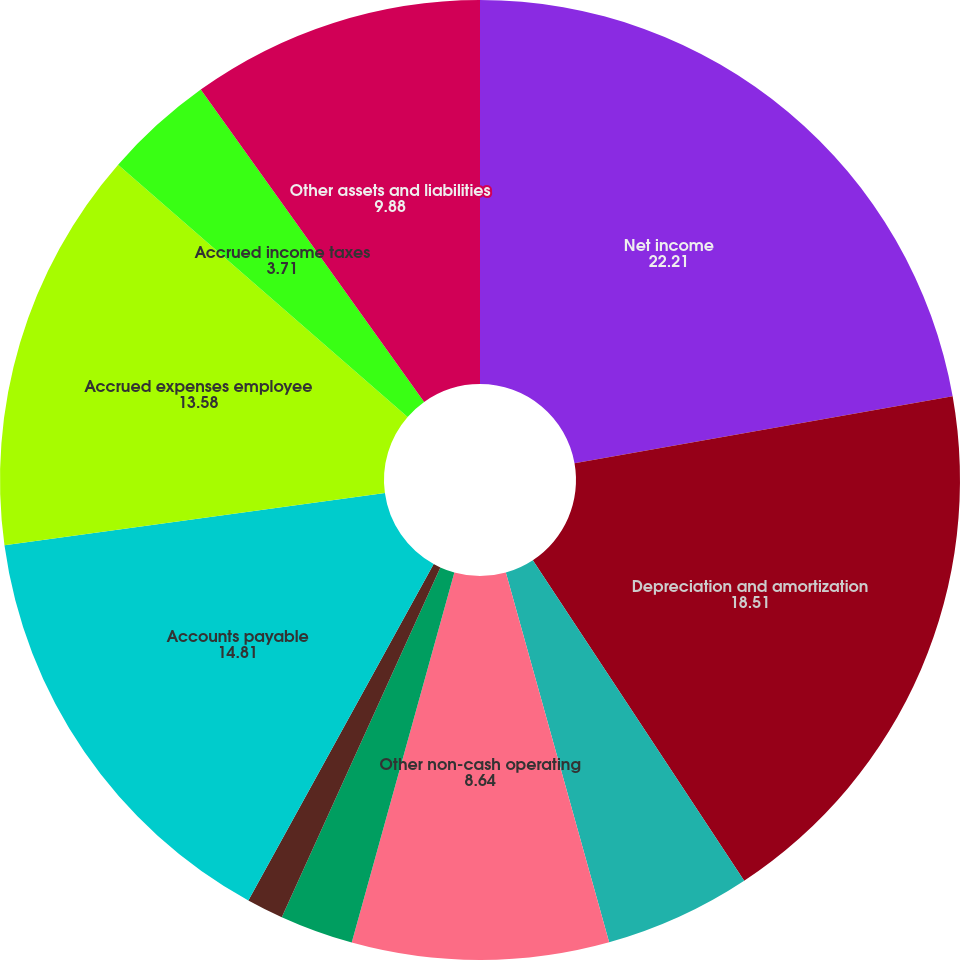Convert chart. <chart><loc_0><loc_0><loc_500><loc_500><pie_chart><fcel>Net income<fcel>Depreciation and amortization<fcel>Deferred income taxes<fcel>Other non-cash operating<fcel>Accounts receivable<fcel>Inventories<fcel>Accounts payable<fcel>Accrued expenses employee<fcel>Accrued income taxes<fcel>Other assets and liabilities<nl><fcel>22.21%<fcel>18.51%<fcel>4.94%<fcel>8.64%<fcel>2.47%<fcel>1.24%<fcel>14.81%<fcel>13.58%<fcel>3.71%<fcel>9.88%<nl></chart> 